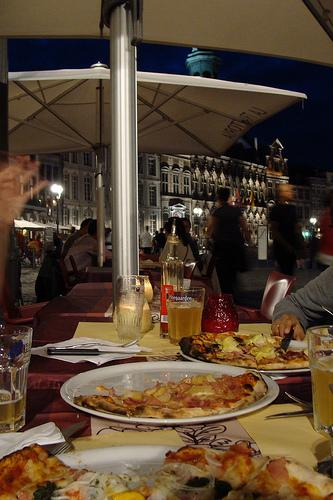Combine the elements in the image that refer to a specific gathering or social event. A party of diners could be enjoying their time under an umbrella in a restaurant, with a cheese pizza on a table, surrounded by a glass of beer, a clear water glass, and a red candle holder. Please provide a detailed description of the primary object in the image, including its appearance and surroundings. The main object in the image is a cheese pizza on a white plate, which has a piece missing, placed on a table with a knife, a glass of beer, a clear water glass, and a red candle holder nearby. People can be seen in the background sitting and standing in what appears to be a restaurant setting. Based on the contents of the image, what kind of advertisement could this scene be used for? The image could be used for advertising a restaurant or pizzeria, promoting their delicious pizza, relaxed atmosphere, and complementary beverages such as beer. Explain the background scene and the context it provides for the image. In the background, there are people sitting and standing, possibly chatting or enjoying their meals, which indicates that the photo was taken in a social, dining setting like a restaurant. Mention the type of drink that accompanies the food in the image and describe its container. A glass of beer accompanies the pizza, and it is in a transparent glass with a thin stem. What is the current state of the pizza and what could be its prospective consumption status? The pizza has one piece missing, which indicates that it's almost whole, and it appears to be freshly served, suggesting that it will be consumed by the diners soon. Describe the table setup, including the cutlery and tableware presented alongside the food. The table setup includes a white plate holding the pizza, a knife resting on a napkin, a clear water glass, and a red candle holder. A glass of beer is also present on the table. Based on the image, can you infer the general atmosphere and type of establishment where the picture was taken? The image suggests that this is a restaurant with a casual and relaxed atmosphere, as people can be seen in the background sitting and standing, possibly enjoying their meals or conversing. Can you identify the type of food and its specific characteristics that are visible in the picture? The food displayed is a delicious thin-crust cheese pizza with tomato sauce and a slightly burnt crust, with a piece missing, presented on a white plate on a table. Describe the visual aspects of the image that imply a specific type of cuisine or dining experience. The presence of a thin-crust cheese pizza, tomato sauce, and a glass of beer suggests an Italian or casual dining experience. 